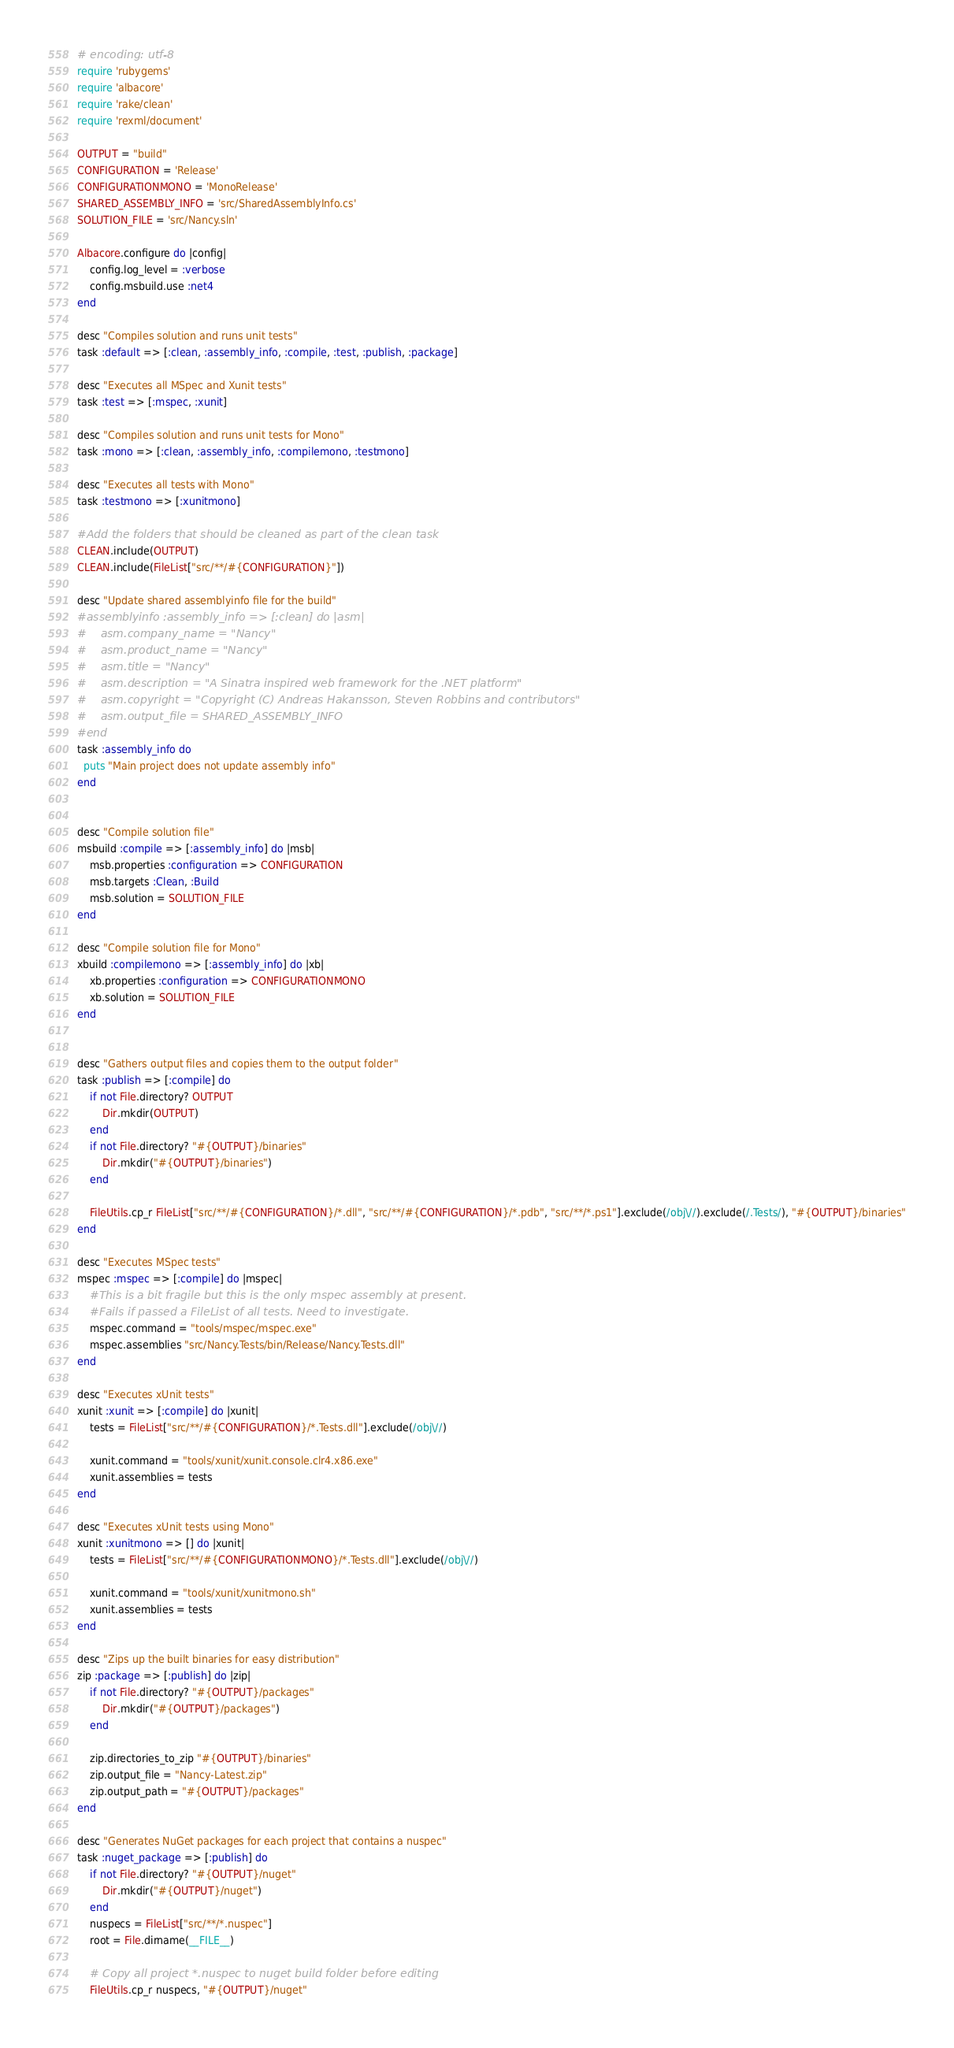<code> <loc_0><loc_0><loc_500><loc_500><_Ruby_># encoding: utf-8
require 'rubygems'
require 'albacore'
require 'rake/clean'
require 'rexml/document'

OUTPUT = "build"
CONFIGURATION = 'Release'
CONFIGURATIONMONO = 'MonoRelease'
SHARED_ASSEMBLY_INFO = 'src/SharedAssemblyInfo.cs'
SOLUTION_FILE = 'src/Nancy.sln'

Albacore.configure do |config|
    config.log_level = :verbose
    config.msbuild.use :net4
end

desc "Compiles solution and runs unit tests"
task :default => [:clean, :assembly_info, :compile, :test, :publish, :package]

desc "Executes all MSpec and Xunit tests"
task :test => [:mspec, :xunit]

desc "Compiles solution and runs unit tests for Mono"
task :mono => [:clean, :assembly_info, :compilemono, :testmono]

desc "Executes all tests with Mono"
task :testmono => [:xunitmono]

#Add the folders that should be cleaned as part of the clean task
CLEAN.include(OUTPUT)
CLEAN.include(FileList["src/**/#{CONFIGURATION}"])

desc "Update shared assemblyinfo file for the build"
#assemblyinfo :assembly_info => [:clean] do |asm|
#    asm.company_name = "Nancy"
#    asm.product_name = "Nancy"
#    asm.title = "Nancy"
#    asm.description = "A Sinatra inspired web framework for the .NET platform"
#    asm.copyright = "Copyright (C) Andreas Hakansson, Steven Robbins and contributors"
#    asm.output_file = SHARED_ASSEMBLY_INFO
#end
task :assembly_info do
  puts "Main project does not update assembly info"
end


desc "Compile solution file"
msbuild :compile => [:assembly_info] do |msb|
    msb.properties :configuration => CONFIGURATION
    msb.targets :Clean, :Build
    msb.solution = SOLUTION_FILE
end

desc "Compile solution file for Mono"
xbuild :compilemono => [:assembly_info] do |xb|
    xb.properties :configuration => CONFIGURATIONMONO
    xb.solution = SOLUTION_FILE
end


desc "Gathers output files and copies them to the output folder"
task :publish => [:compile] do
    if not File.directory? OUTPUT
        Dir.mkdir(OUTPUT)
    end
    if not File.directory? "#{OUTPUT}/binaries"
        Dir.mkdir("#{OUTPUT}/binaries")
    end

    FileUtils.cp_r FileList["src/**/#{CONFIGURATION}/*.dll", "src/**/#{CONFIGURATION}/*.pdb", "src/**/*.ps1"].exclude(/obj\//).exclude(/.Tests/), "#{OUTPUT}/binaries"
end

desc "Executes MSpec tests"
mspec :mspec => [:compile] do |mspec|
    #This is a bit fragile but this is the only mspec assembly at present. 
    #Fails if passed a FileList of all tests. Need to investigate.
    mspec.command = "tools/mspec/mspec.exe"
    mspec.assemblies "src/Nancy.Tests/bin/Release/Nancy.Tests.dll"
end

desc "Executes xUnit tests"
xunit :xunit => [:compile] do |xunit|
    tests = FileList["src/**/#{CONFIGURATION}/*.Tests.dll"].exclude(/obj\//)

    xunit.command = "tools/xunit/xunit.console.clr4.x86.exe"
    xunit.assemblies = tests
end 

desc "Executes xUnit tests using Mono"
xunit :xunitmono => [] do |xunit|
    tests = FileList["src/**/#{CONFIGURATIONMONO}/*.Tests.dll"].exclude(/obj\//)

    xunit.command = "tools/xunit/xunitmono.sh"
    xunit.assemblies = tests
end

desc "Zips up the built binaries for easy distribution"
zip :package => [:publish] do |zip|
    if not File.directory? "#{OUTPUT}/packages"
        Dir.mkdir("#{OUTPUT}/packages")
    end

    zip.directories_to_zip "#{OUTPUT}/binaries"
    zip.output_file = "Nancy-Latest.zip"
    zip.output_path = "#{OUTPUT}/packages"
end

desc "Generates NuGet packages for each project that contains a nuspec"
task :nuget_package => [:publish] do
    if not File.directory? "#{OUTPUT}/nuget"
        Dir.mkdir("#{OUTPUT}/nuget")
    end
    nuspecs = FileList["src/**/*.nuspec"]
    root = File.dirname(__FILE__)

    # Copy all project *.nuspec to nuget build folder before editing
    FileUtils.cp_r nuspecs, "#{OUTPUT}/nuget"</code> 